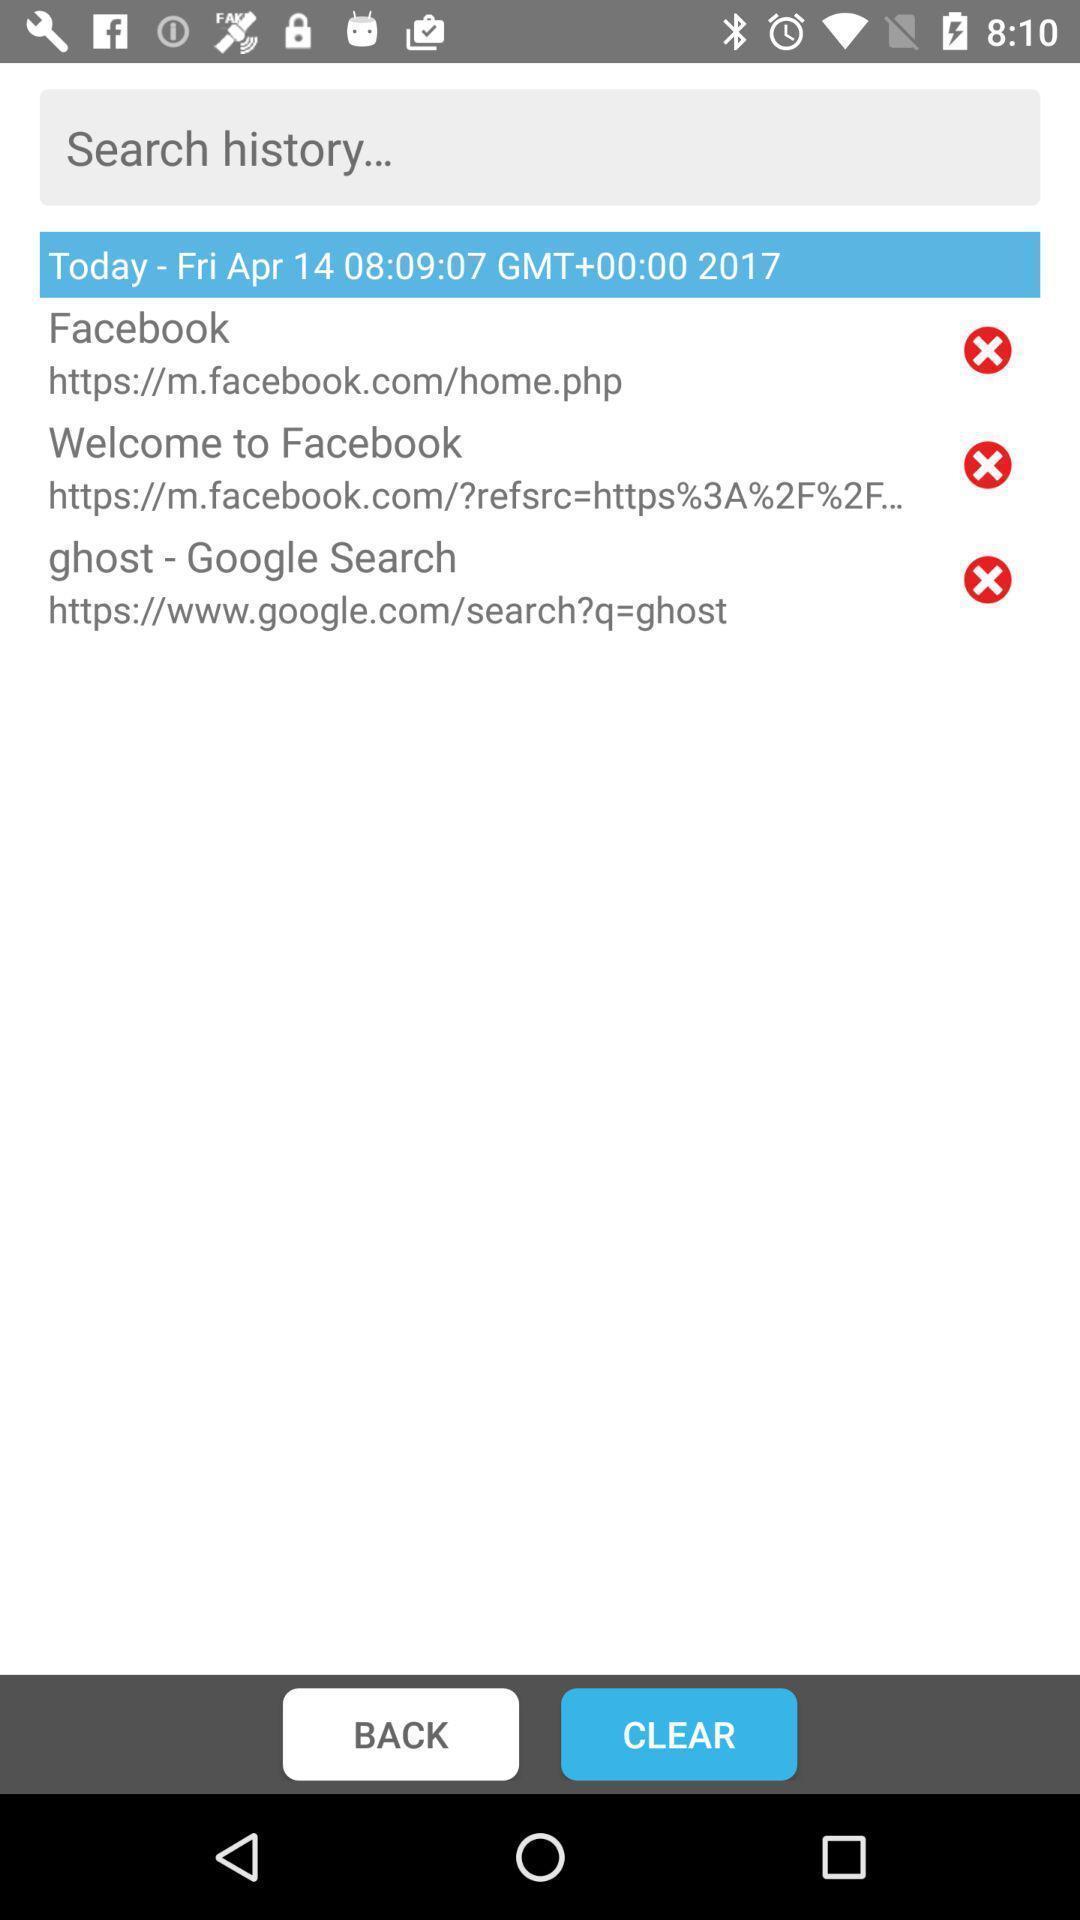Give me a summary of this screen capture. Search page of history. 